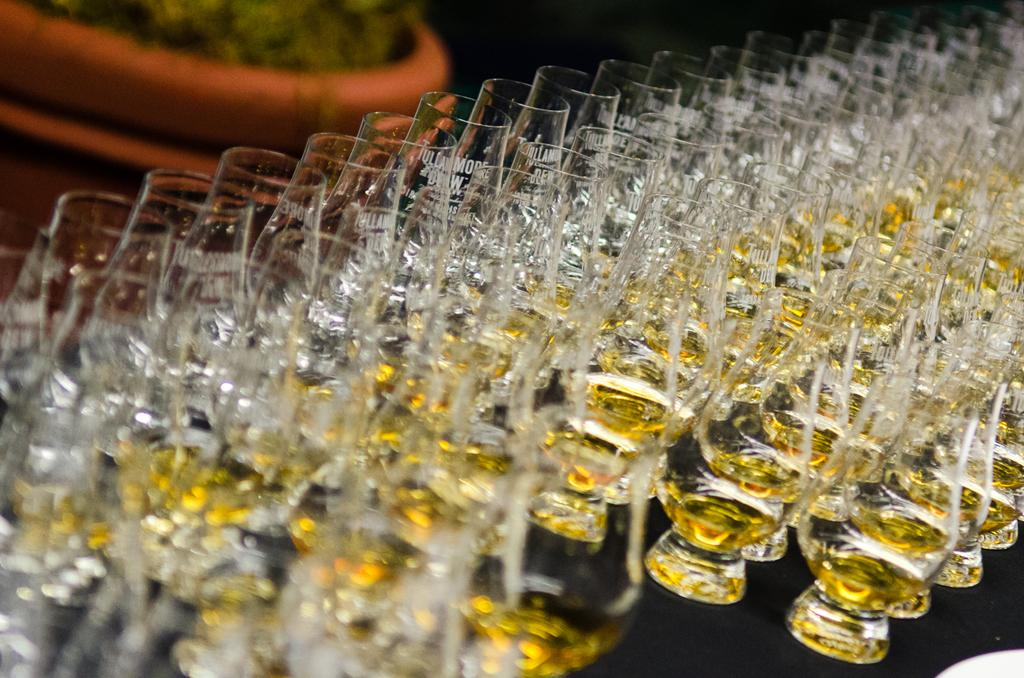What type of beverages are in the glasses in the image? There are glasses of drinks in the image, but the specific type of drinks is not mentioned. What can be seen in the background of the image? There appears to be a plant in the background of the image. What notes can be seen in the notebook on the table in the image? There is no notebook present in the image; it only mentions glasses of drinks and a plant in the background. What type of milk is being served in the glasses in the image? The type of drinks in the glasses is not specified, so it cannot be determined if they are milk or any other beverage. 